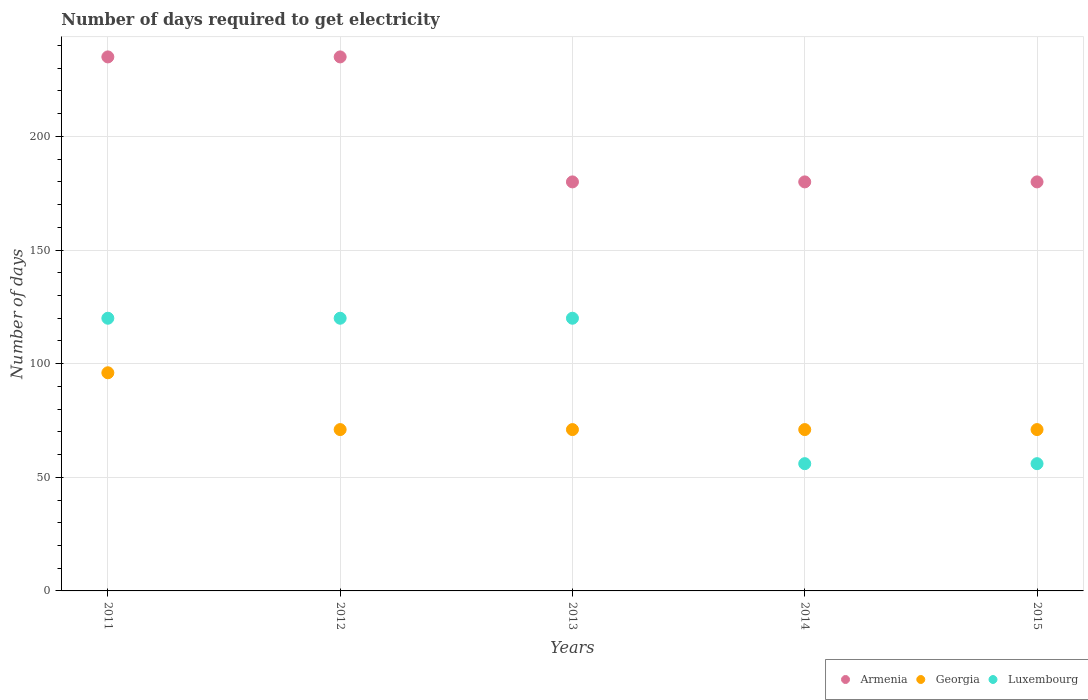What is the number of days required to get electricity in in Luxembourg in 2014?
Make the answer very short. 56. Across all years, what is the maximum number of days required to get electricity in in Luxembourg?
Provide a short and direct response. 120. Across all years, what is the minimum number of days required to get electricity in in Armenia?
Your answer should be very brief. 180. In which year was the number of days required to get electricity in in Luxembourg maximum?
Your response must be concise. 2011. In which year was the number of days required to get electricity in in Luxembourg minimum?
Provide a succinct answer. 2014. What is the total number of days required to get electricity in in Georgia in the graph?
Your answer should be very brief. 380. What is the difference between the number of days required to get electricity in in Georgia in 2011 and that in 2012?
Ensure brevity in your answer.  25. What is the difference between the number of days required to get electricity in in Georgia in 2014 and the number of days required to get electricity in in Armenia in 2012?
Provide a short and direct response. -164. What is the average number of days required to get electricity in in Armenia per year?
Provide a short and direct response. 202. In the year 2013, what is the difference between the number of days required to get electricity in in Armenia and number of days required to get electricity in in Luxembourg?
Your answer should be very brief. 60. In how many years, is the number of days required to get electricity in in Georgia greater than 160 days?
Your answer should be compact. 0. What is the ratio of the number of days required to get electricity in in Georgia in 2012 to that in 2015?
Make the answer very short. 1. What is the difference between the highest and the second highest number of days required to get electricity in in Armenia?
Provide a short and direct response. 0. What is the difference between the highest and the lowest number of days required to get electricity in in Luxembourg?
Offer a very short reply. 64. In how many years, is the number of days required to get electricity in in Armenia greater than the average number of days required to get electricity in in Armenia taken over all years?
Make the answer very short. 2. Is it the case that in every year, the sum of the number of days required to get electricity in in Armenia and number of days required to get electricity in in Luxembourg  is greater than the number of days required to get electricity in in Georgia?
Make the answer very short. Yes. Does the number of days required to get electricity in in Armenia monotonically increase over the years?
Make the answer very short. No. Is the number of days required to get electricity in in Georgia strictly greater than the number of days required to get electricity in in Luxembourg over the years?
Your response must be concise. No. How many dotlines are there?
Provide a succinct answer. 3. What is the difference between two consecutive major ticks on the Y-axis?
Your answer should be compact. 50. Are the values on the major ticks of Y-axis written in scientific E-notation?
Keep it short and to the point. No. Does the graph contain any zero values?
Your answer should be compact. No. How are the legend labels stacked?
Your answer should be very brief. Horizontal. What is the title of the graph?
Give a very brief answer. Number of days required to get electricity. Does "Papua New Guinea" appear as one of the legend labels in the graph?
Ensure brevity in your answer.  No. What is the label or title of the Y-axis?
Your response must be concise. Number of days. What is the Number of days of Armenia in 2011?
Offer a very short reply. 235. What is the Number of days in Georgia in 2011?
Make the answer very short. 96. What is the Number of days of Luxembourg in 2011?
Offer a very short reply. 120. What is the Number of days of Armenia in 2012?
Keep it short and to the point. 235. What is the Number of days in Georgia in 2012?
Your answer should be compact. 71. What is the Number of days in Luxembourg in 2012?
Give a very brief answer. 120. What is the Number of days in Armenia in 2013?
Offer a terse response. 180. What is the Number of days of Georgia in 2013?
Offer a very short reply. 71. What is the Number of days in Luxembourg in 2013?
Keep it short and to the point. 120. What is the Number of days of Armenia in 2014?
Keep it short and to the point. 180. What is the Number of days of Armenia in 2015?
Offer a very short reply. 180. What is the Number of days in Georgia in 2015?
Make the answer very short. 71. Across all years, what is the maximum Number of days in Armenia?
Keep it short and to the point. 235. Across all years, what is the maximum Number of days of Georgia?
Your answer should be very brief. 96. Across all years, what is the maximum Number of days in Luxembourg?
Ensure brevity in your answer.  120. Across all years, what is the minimum Number of days of Armenia?
Your answer should be very brief. 180. Across all years, what is the minimum Number of days of Georgia?
Your answer should be very brief. 71. Across all years, what is the minimum Number of days of Luxembourg?
Offer a terse response. 56. What is the total Number of days of Armenia in the graph?
Offer a very short reply. 1010. What is the total Number of days of Georgia in the graph?
Your response must be concise. 380. What is the total Number of days of Luxembourg in the graph?
Make the answer very short. 472. What is the difference between the Number of days in Georgia in 2011 and that in 2012?
Provide a short and direct response. 25. What is the difference between the Number of days of Luxembourg in 2011 and that in 2012?
Ensure brevity in your answer.  0. What is the difference between the Number of days of Armenia in 2011 and that in 2013?
Your answer should be very brief. 55. What is the difference between the Number of days of Georgia in 2011 and that in 2013?
Ensure brevity in your answer.  25. What is the difference between the Number of days in Armenia in 2011 and that in 2014?
Your answer should be compact. 55. What is the difference between the Number of days in Georgia in 2011 and that in 2014?
Your answer should be very brief. 25. What is the difference between the Number of days in Luxembourg in 2011 and that in 2014?
Offer a terse response. 64. What is the difference between the Number of days of Armenia in 2012 and that in 2014?
Give a very brief answer. 55. What is the difference between the Number of days in Georgia in 2012 and that in 2014?
Offer a terse response. 0. What is the difference between the Number of days of Armenia in 2013 and that in 2015?
Your response must be concise. 0. What is the difference between the Number of days of Armenia in 2011 and the Number of days of Georgia in 2012?
Give a very brief answer. 164. What is the difference between the Number of days of Armenia in 2011 and the Number of days of Luxembourg in 2012?
Your answer should be very brief. 115. What is the difference between the Number of days of Georgia in 2011 and the Number of days of Luxembourg in 2012?
Keep it short and to the point. -24. What is the difference between the Number of days in Armenia in 2011 and the Number of days in Georgia in 2013?
Offer a terse response. 164. What is the difference between the Number of days in Armenia in 2011 and the Number of days in Luxembourg in 2013?
Ensure brevity in your answer.  115. What is the difference between the Number of days in Armenia in 2011 and the Number of days in Georgia in 2014?
Make the answer very short. 164. What is the difference between the Number of days of Armenia in 2011 and the Number of days of Luxembourg in 2014?
Your answer should be very brief. 179. What is the difference between the Number of days in Georgia in 2011 and the Number of days in Luxembourg in 2014?
Provide a short and direct response. 40. What is the difference between the Number of days of Armenia in 2011 and the Number of days of Georgia in 2015?
Provide a succinct answer. 164. What is the difference between the Number of days in Armenia in 2011 and the Number of days in Luxembourg in 2015?
Give a very brief answer. 179. What is the difference between the Number of days of Armenia in 2012 and the Number of days of Georgia in 2013?
Give a very brief answer. 164. What is the difference between the Number of days of Armenia in 2012 and the Number of days of Luxembourg in 2013?
Make the answer very short. 115. What is the difference between the Number of days of Georgia in 2012 and the Number of days of Luxembourg in 2013?
Make the answer very short. -49. What is the difference between the Number of days in Armenia in 2012 and the Number of days in Georgia in 2014?
Give a very brief answer. 164. What is the difference between the Number of days in Armenia in 2012 and the Number of days in Luxembourg in 2014?
Provide a succinct answer. 179. What is the difference between the Number of days in Georgia in 2012 and the Number of days in Luxembourg in 2014?
Provide a succinct answer. 15. What is the difference between the Number of days of Armenia in 2012 and the Number of days of Georgia in 2015?
Your answer should be very brief. 164. What is the difference between the Number of days in Armenia in 2012 and the Number of days in Luxembourg in 2015?
Make the answer very short. 179. What is the difference between the Number of days of Georgia in 2012 and the Number of days of Luxembourg in 2015?
Ensure brevity in your answer.  15. What is the difference between the Number of days of Armenia in 2013 and the Number of days of Georgia in 2014?
Make the answer very short. 109. What is the difference between the Number of days of Armenia in 2013 and the Number of days of Luxembourg in 2014?
Your answer should be very brief. 124. What is the difference between the Number of days of Armenia in 2013 and the Number of days of Georgia in 2015?
Provide a short and direct response. 109. What is the difference between the Number of days in Armenia in 2013 and the Number of days in Luxembourg in 2015?
Make the answer very short. 124. What is the difference between the Number of days in Armenia in 2014 and the Number of days in Georgia in 2015?
Make the answer very short. 109. What is the difference between the Number of days of Armenia in 2014 and the Number of days of Luxembourg in 2015?
Provide a short and direct response. 124. What is the average Number of days of Armenia per year?
Your answer should be compact. 202. What is the average Number of days of Georgia per year?
Your answer should be very brief. 76. What is the average Number of days in Luxembourg per year?
Your response must be concise. 94.4. In the year 2011, what is the difference between the Number of days of Armenia and Number of days of Georgia?
Your response must be concise. 139. In the year 2011, what is the difference between the Number of days of Armenia and Number of days of Luxembourg?
Offer a very short reply. 115. In the year 2011, what is the difference between the Number of days in Georgia and Number of days in Luxembourg?
Your answer should be compact. -24. In the year 2012, what is the difference between the Number of days in Armenia and Number of days in Georgia?
Your answer should be compact. 164. In the year 2012, what is the difference between the Number of days in Armenia and Number of days in Luxembourg?
Your response must be concise. 115. In the year 2012, what is the difference between the Number of days in Georgia and Number of days in Luxembourg?
Make the answer very short. -49. In the year 2013, what is the difference between the Number of days of Armenia and Number of days of Georgia?
Keep it short and to the point. 109. In the year 2013, what is the difference between the Number of days in Georgia and Number of days in Luxembourg?
Your answer should be very brief. -49. In the year 2014, what is the difference between the Number of days in Armenia and Number of days in Georgia?
Provide a short and direct response. 109. In the year 2014, what is the difference between the Number of days in Armenia and Number of days in Luxembourg?
Keep it short and to the point. 124. In the year 2014, what is the difference between the Number of days of Georgia and Number of days of Luxembourg?
Your response must be concise. 15. In the year 2015, what is the difference between the Number of days of Armenia and Number of days of Georgia?
Offer a very short reply. 109. In the year 2015, what is the difference between the Number of days of Armenia and Number of days of Luxembourg?
Keep it short and to the point. 124. What is the ratio of the Number of days in Georgia in 2011 to that in 2012?
Provide a short and direct response. 1.35. What is the ratio of the Number of days in Luxembourg in 2011 to that in 2012?
Ensure brevity in your answer.  1. What is the ratio of the Number of days of Armenia in 2011 to that in 2013?
Offer a terse response. 1.31. What is the ratio of the Number of days of Georgia in 2011 to that in 2013?
Offer a very short reply. 1.35. What is the ratio of the Number of days of Luxembourg in 2011 to that in 2013?
Provide a succinct answer. 1. What is the ratio of the Number of days of Armenia in 2011 to that in 2014?
Offer a very short reply. 1.31. What is the ratio of the Number of days of Georgia in 2011 to that in 2014?
Your answer should be very brief. 1.35. What is the ratio of the Number of days of Luxembourg in 2011 to that in 2014?
Offer a very short reply. 2.14. What is the ratio of the Number of days in Armenia in 2011 to that in 2015?
Give a very brief answer. 1.31. What is the ratio of the Number of days in Georgia in 2011 to that in 2015?
Your answer should be very brief. 1.35. What is the ratio of the Number of days in Luxembourg in 2011 to that in 2015?
Make the answer very short. 2.14. What is the ratio of the Number of days of Armenia in 2012 to that in 2013?
Make the answer very short. 1.31. What is the ratio of the Number of days in Armenia in 2012 to that in 2014?
Give a very brief answer. 1.31. What is the ratio of the Number of days in Georgia in 2012 to that in 2014?
Provide a short and direct response. 1. What is the ratio of the Number of days in Luxembourg in 2012 to that in 2014?
Provide a short and direct response. 2.14. What is the ratio of the Number of days of Armenia in 2012 to that in 2015?
Keep it short and to the point. 1.31. What is the ratio of the Number of days in Luxembourg in 2012 to that in 2015?
Your response must be concise. 2.14. What is the ratio of the Number of days of Luxembourg in 2013 to that in 2014?
Provide a short and direct response. 2.14. What is the ratio of the Number of days of Luxembourg in 2013 to that in 2015?
Keep it short and to the point. 2.14. What is the ratio of the Number of days in Armenia in 2014 to that in 2015?
Give a very brief answer. 1. What is the difference between the highest and the second highest Number of days in Georgia?
Offer a very short reply. 25. What is the difference between the highest and the second highest Number of days of Luxembourg?
Your answer should be very brief. 0. 